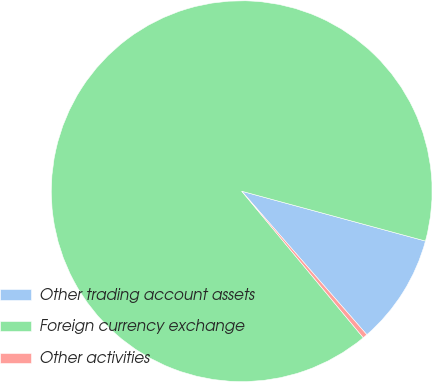<chart> <loc_0><loc_0><loc_500><loc_500><pie_chart><fcel>Other trading account assets<fcel>Foreign currency exchange<fcel>Other activities<nl><fcel>9.37%<fcel>90.24%<fcel>0.39%<nl></chart> 